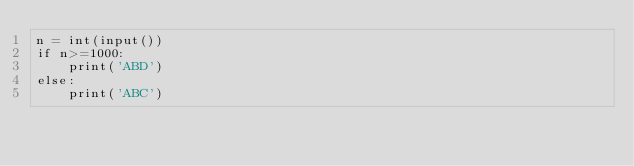Convert code to text. <code><loc_0><loc_0><loc_500><loc_500><_Python_>n = int(input())
if n>=1000:
    print('ABD')
else:
    print('ABC')</code> 